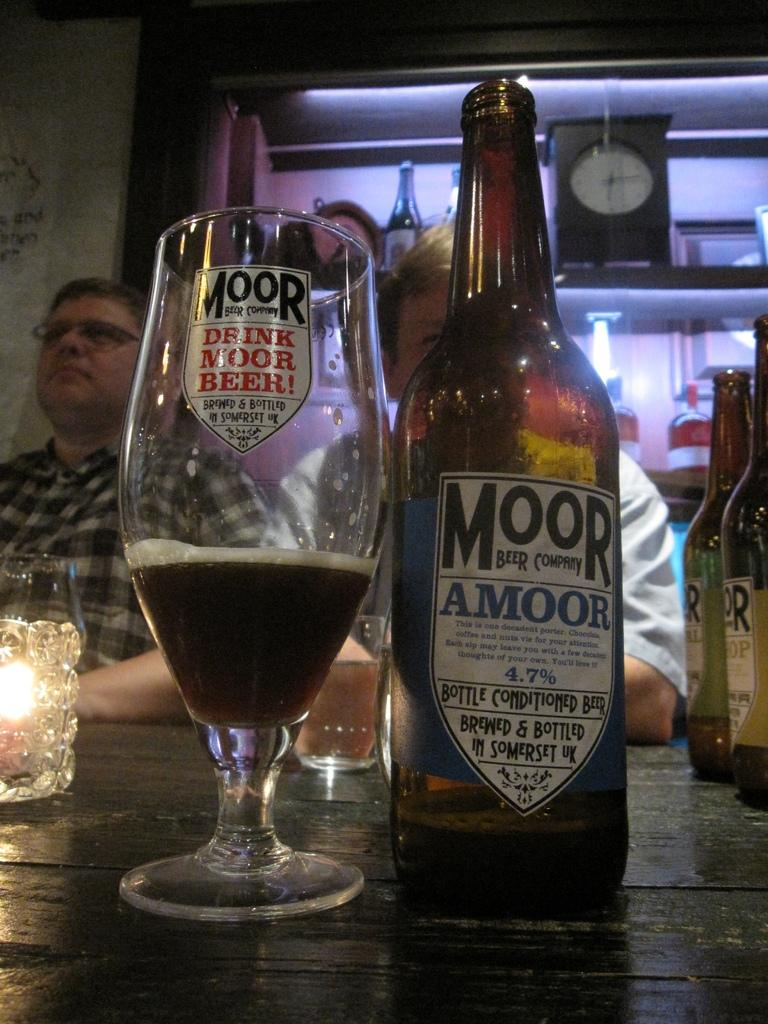What piece of furniture is present in the image? There is a table in the image. What is placed on the table? There is a wine bottle and a wine glass on the table. Are there any people visible in the image? Yes, people are standing at the back of the image. How does the tongue of the person in the image compare to the size of the wine glass? There is no information about the tongue of the person in the image, so it cannot be compared to the size of the wine glass. 